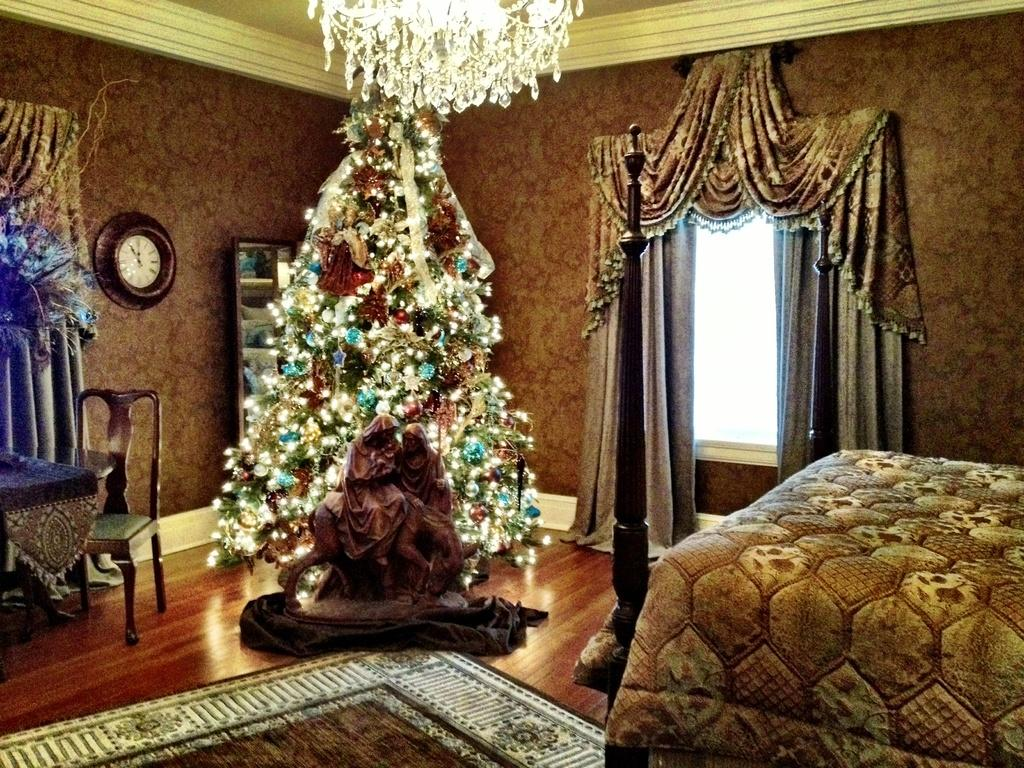What type of structure can be seen in the image? There is a wall in the image. What time-telling device is present in the image? There is a clock in the image. What allows light and air into the room in the image? There is a window in the image. What type of window treatment is visible in the image? There are curtains in the image. What seasonal decoration is present in the image? There is a Christmas tree in the image. What type of ornament is present in the image? There is a statue in the image. What piece of furniture is located on the right side of the image? There is a bed on the right side of the image. Can you tell me how many rings the statue is wearing in the image? There is no mention of rings or any jewelry on the statue in the image. Who is the aunt in the image? There is no reference to an aunt or any family members in the image. 